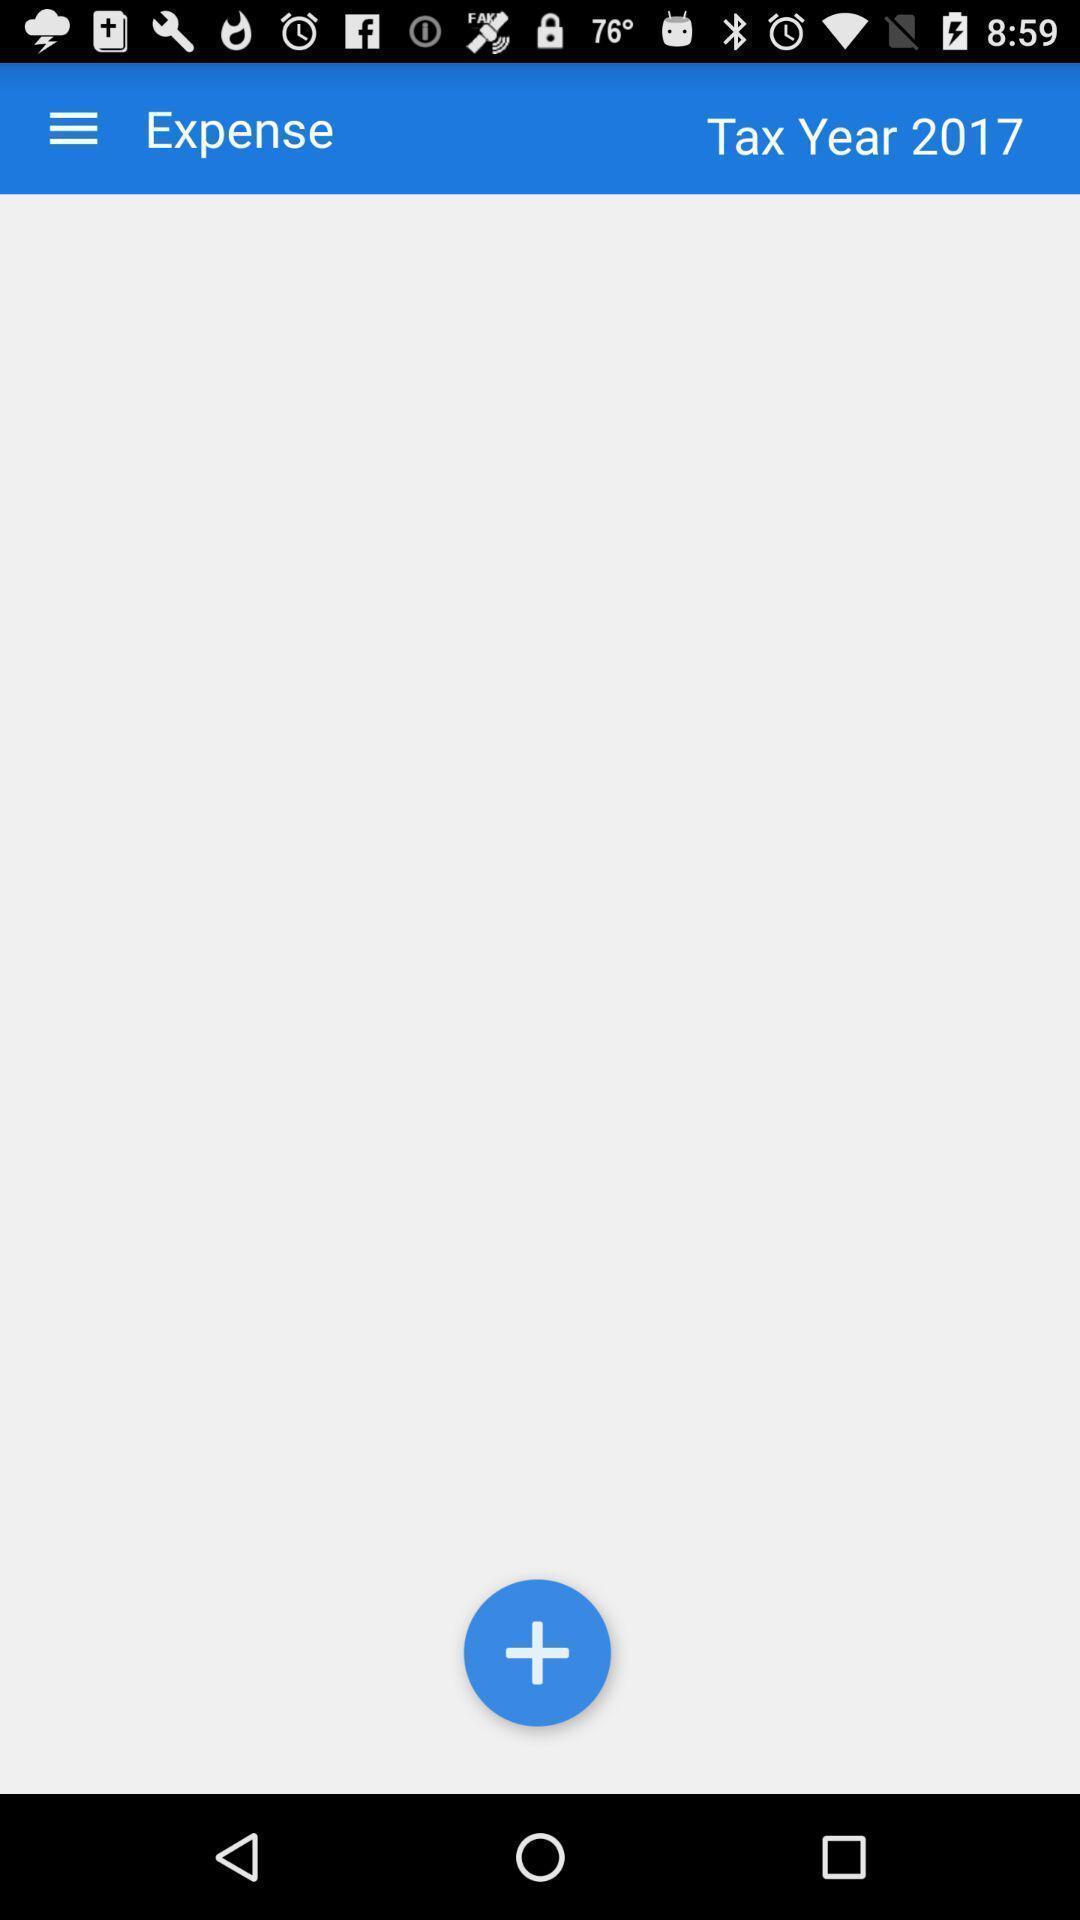Describe this image in words. Page of tax year expense. 